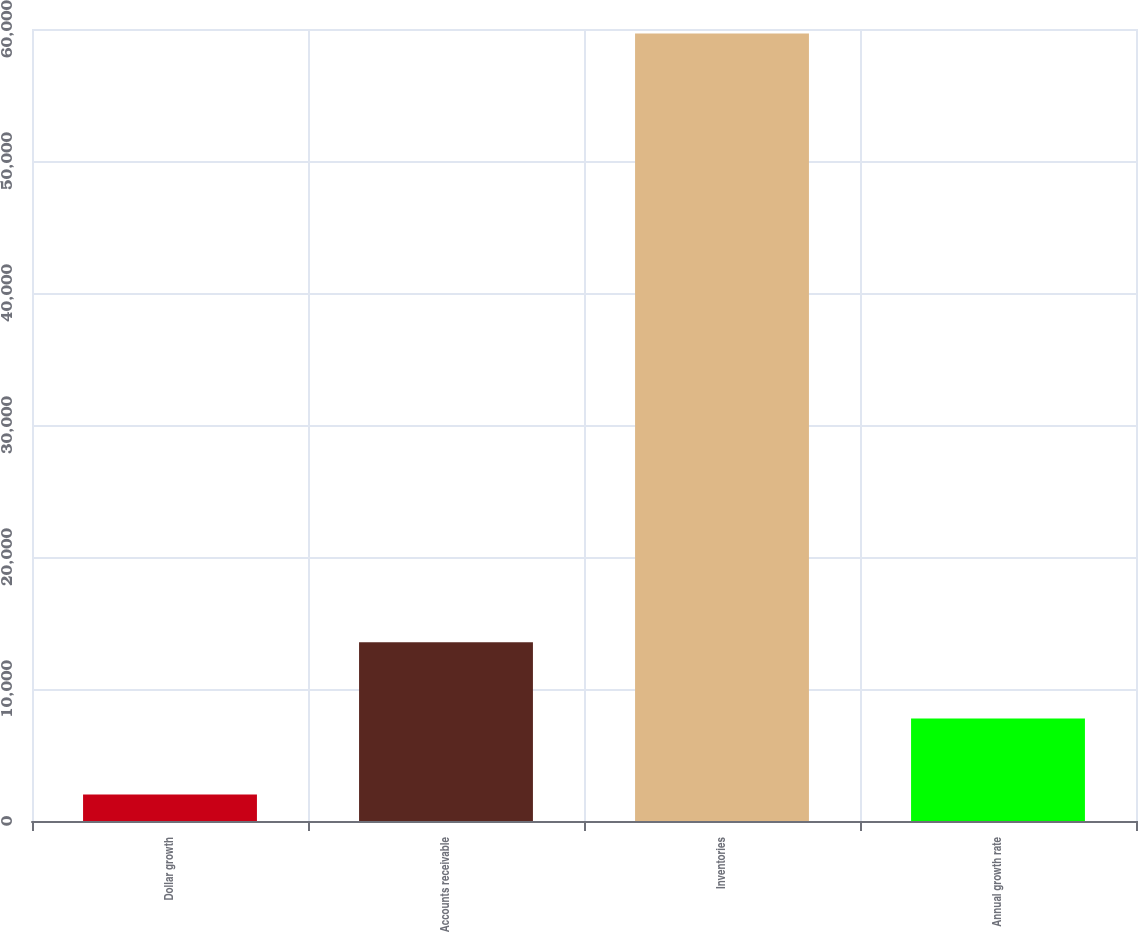Convert chart to OTSL. <chart><loc_0><loc_0><loc_500><loc_500><bar_chart><fcel>Dollar growth<fcel>Accounts receivable<fcel>Inventories<fcel>Annual growth rate<nl><fcel>2008<fcel>13537.4<fcel>59655<fcel>7772.7<nl></chart> 